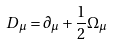Convert formula to latex. <formula><loc_0><loc_0><loc_500><loc_500>D _ { \mu } = \partial _ { \mu } + { \frac { 1 } { 2 } } \Omega _ { \mu }</formula> 